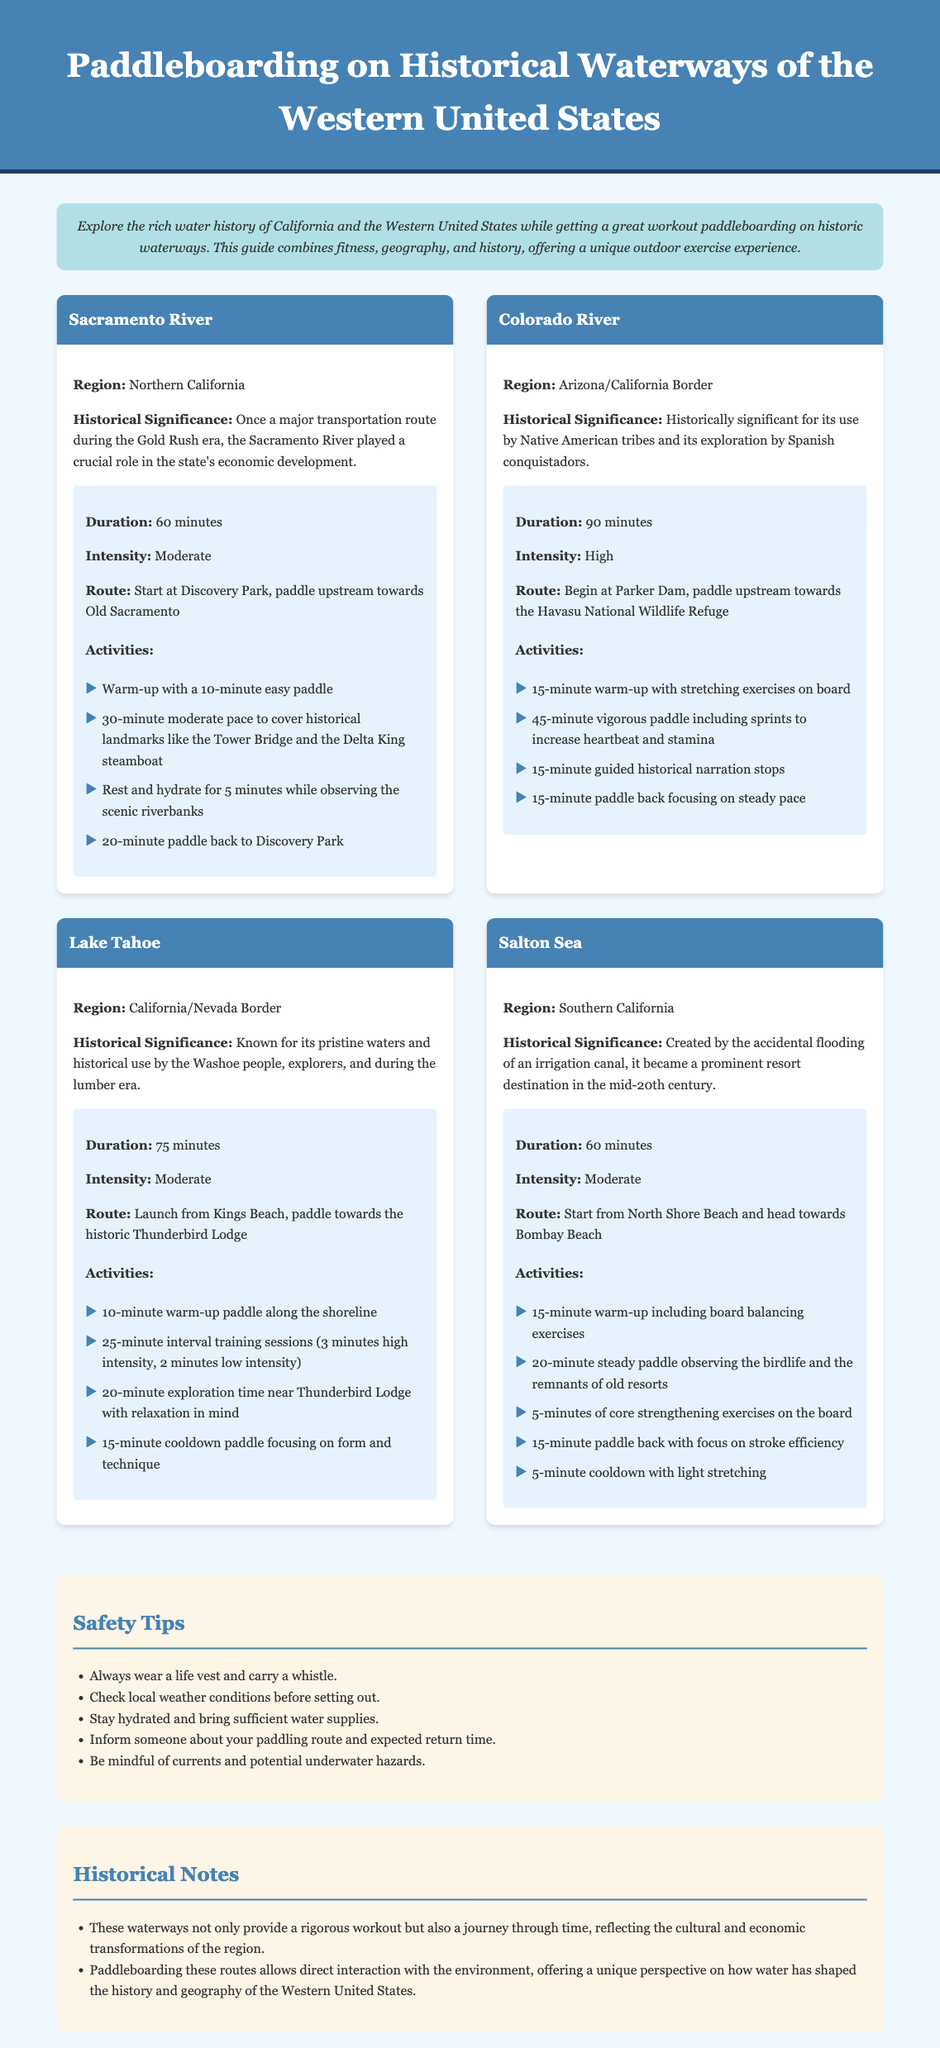What is the duration for paddleboarding on the Sacramento River? The document states that the duration for paddleboarding on the Sacramento River is 60 minutes.
Answer: 60 minutes What is the historical significance of the Colorado River? The document mentions that the Colorado River is historically significant for its use by Native American tribes and its exploration by Spanish conquistadors.
Answer: Use by Native American tribes and exploration by Spanish conquistadors What is one safety tip provided in the document? One of the safety tips listed in the document is to always wear a life vest and carry a whistle.
Answer: Always wear a life vest and carry a whistle What is the high intensity workout duration on the Colorado River? The Colorado River workout plan indicates that the high intensity section lasts for 45 minutes.
Answer: 45 minutes Which waterway has a workout plan that starts at North Shore Beach? The document specifies that the Salton Sea workout plan starts at North Shore Beach.
Answer: Salton Sea How long should you warm-up before paddleboarding on Lake Tahoe? The workout plan for Lake Tahoe suggests a 10-minute warm-up paddle along the shoreline.
Answer: 10 minutes What type of activities are included in the Salton Sea paddleboarding routine? The Salton Sea paddleboarding routine includes warm-up exercises, steady paddling, core strengthening exercises, and cooldown stretching.
Answer: Warm-up exercises, steady paddling, core strengthening exercises, cooldown stretching What is the warm-up duration for the Sacramento River plan? The warm-up for the Sacramento River plan is listed as 10 minutes.
Answer: 10 minutes What does the document suggest to bring for hydration? The document emphasizes the importance of bringing sufficient water supplies for hydration.
Answer: Sufficient water supplies 